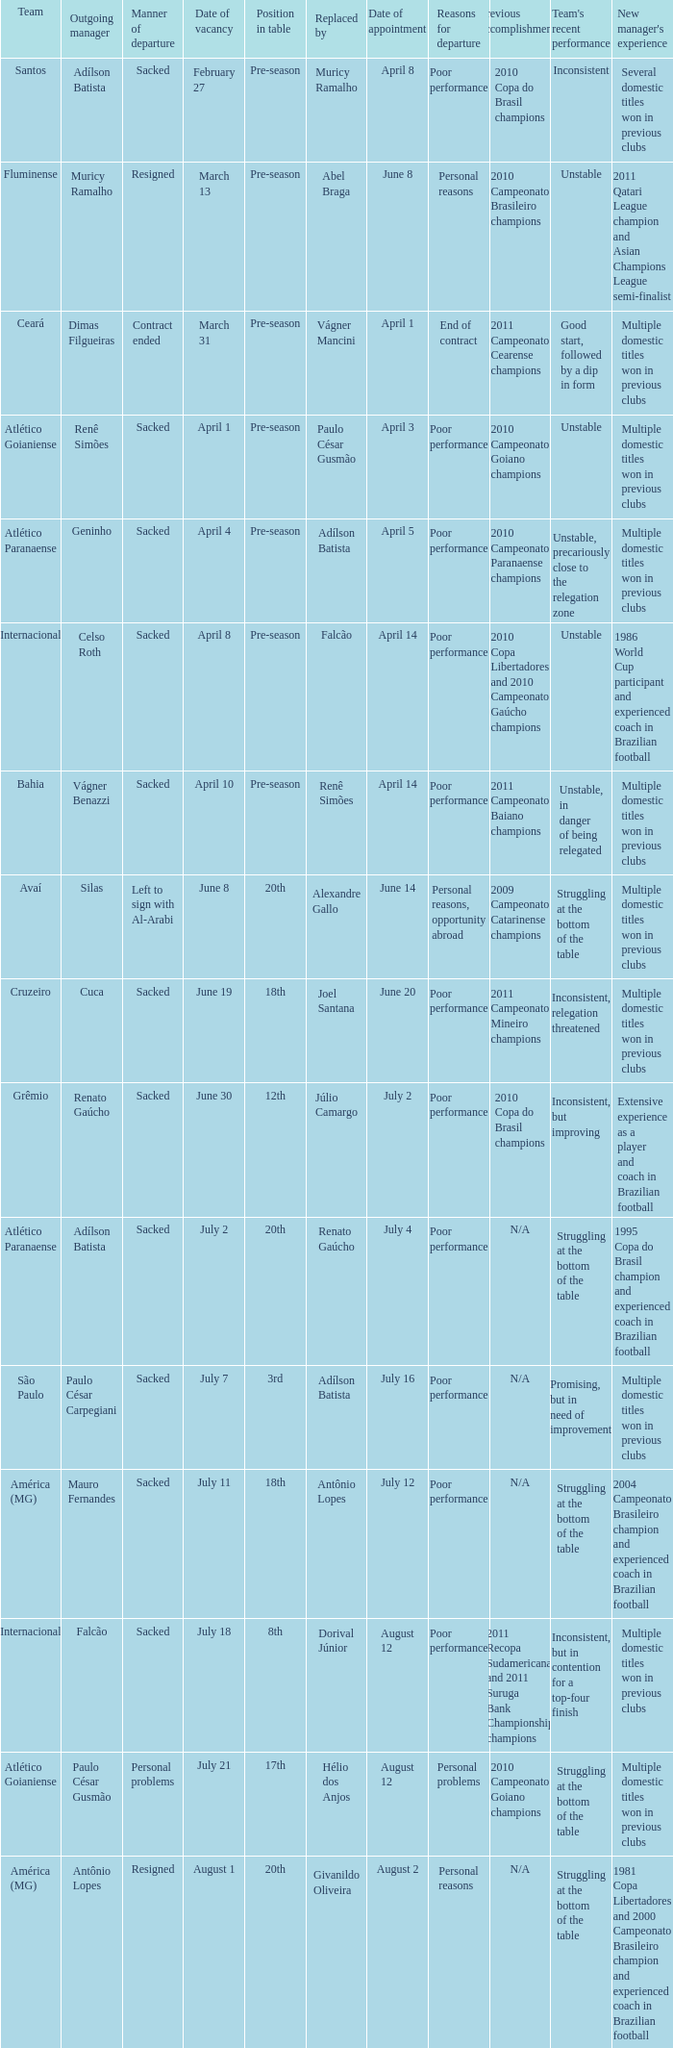How many times did Silas leave as a team manager? 1.0. 